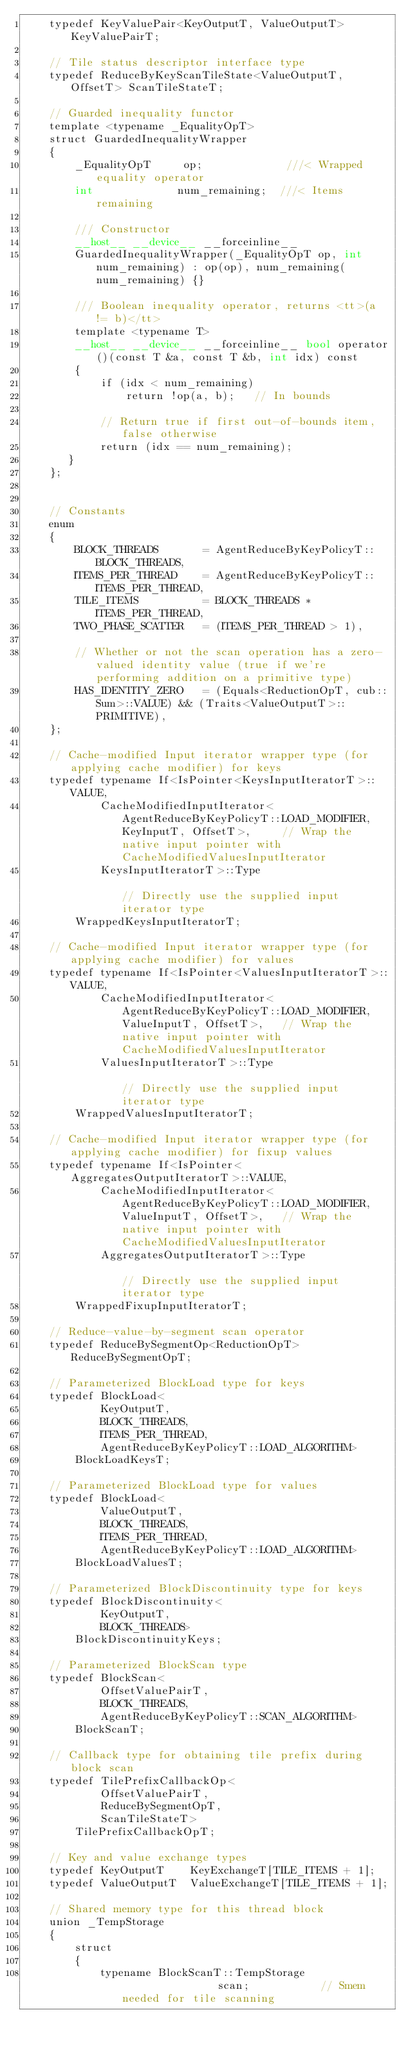<code> <loc_0><loc_0><loc_500><loc_500><_Cuda_>    typedef KeyValuePair<KeyOutputT, ValueOutputT> KeyValuePairT;

    // Tile status descriptor interface type
    typedef ReduceByKeyScanTileState<ValueOutputT, OffsetT> ScanTileStateT;

    // Guarded inequality functor
    template <typename _EqualityOpT>
    struct GuardedInequalityWrapper
    {
        _EqualityOpT     op;             ///< Wrapped equality operator
        int             num_remaining;  ///< Items remaining

        /// Constructor
        __host__ __device__ __forceinline__
        GuardedInequalityWrapper(_EqualityOpT op, int num_remaining) : op(op), num_remaining(num_remaining) {}

        /// Boolean inequality operator, returns <tt>(a != b)</tt>
        template <typename T>
        __host__ __device__ __forceinline__ bool operator()(const T &a, const T &b, int idx) const
        {
            if (idx < num_remaining)
                return !op(a, b);   // In bounds

            // Return true if first out-of-bounds item, false otherwise
            return (idx == num_remaining);
       }
    };


    // Constants
    enum
    {
        BLOCK_THREADS       = AgentReduceByKeyPolicyT::BLOCK_THREADS,
        ITEMS_PER_THREAD    = AgentReduceByKeyPolicyT::ITEMS_PER_THREAD,
        TILE_ITEMS          = BLOCK_THREADS * ITEMS_PER_THREAD,
        TWO_PHASE_SCATTER   = (ITEMS_PER_THREAD > 1),

        // Whether or not the scan operation has a zero-valued identity value (true if we're performing addition on a primitive type)
        HAS_IDENTITY_ZERO   = (Equals<ReductionOpT, cub::Sum>::VALUE) && (Traits<ValueOutputT>::PRIMITIVE),
    };

    // Cache-modified Input iterator wrapper type (for applying cache modifier) for keys
    typedef typename If<IsPointer<KeysInputIteratorT>::VALUE,
            CacheModifiedInputIterator<AgentReduceByKeyPolicyT::LOAD_MODIFIER, KeyInputT, OffsetT>,     // Wrap the native input pointer with CacheModifiedValuesInputIterator
            KeysInputIteratorT>::Type                                                                   // Directly use the supplied input iterator type
        WrappedKeysInputIteratorT;

    // Cache-modified Input iterator wrapper type (for applying cache modifier) for values
    typedef typename If<IsPointer<ValuesInputIteratorT>::VALUE,
            CacheModifiedInputIterator<AgentReduceByKeyPolicyT::LOAD_MODIFIER, ValueInputT, OffsetT>,   // Wrap the native input pointer with CacheModifiedValuesInputIterator
            ValuesInputIteratorT>::Type                                                                 // Directly use the supplied input iterator type
        WrappedValuesInputIteratorT;

    // Cache-modified Input iterator wrapper type (for applying cache modifier) for fixup values
    typedef typename If<IsPointer<AggregatesOutputIteratorT>::VALUE,
            CacheModifiedInputIterator<AgentReduceByKeyPolicyT::LOAD_MODIFIER, ValueInputT, OffsetT>,   // Wrap the native input pointer with CacheModifiedValuesInputIterator
            AggregatesOutputIteratorT>::Type                                                            // Directly use the supplied input iterator type
        WrappedFixupInputIteratorT;

    // Reduce-value-by-segment scan operator
    typedef ReduceBySegmentOp<ReductionOpT> ReduceBySegmentOpT;

    // Parameterized BlockLoad type for keys
    typedef BlockLoad<
            KeyOutputT,
            BLOCK_THREADS,
            ITEMS_PER_THREAD,
            AgentReduceByKeyPolicyT::LOAD_ALGORITHM>
        BlockLoadKeysT;

    // Parameterized BlockLoad type for values
    typedef BlockLoad<
            ValueOutputT,
            BLOCK_THREADS,
            ITEMS_PER_THREAD,
            AgentReduceByKeyPolicyT::LOAD_ALGORITHM>
        BlockLoadValuesT;

    // Parameterized BlockDiscontinuity type for keys
    typedef BlockDiscontinuity<
            KeyOutputT,
            BLOCK_THREADS>
        BlockDiscontinuityKeys;

    // Parameterized BlockScan type
    typedef BlockScan<
            OffsetValuePairT,
            BLOCK_THREADS,
            AgentReduceByKeyPolicyT::SCAN_ALGORITHM>
        BlockScanT;

    // Callback type for obtaining tile prefix during block scan
    typedef TilePrefixCallbackOp<
            OffsetValuePairT,
            ReduceBySegmentOpT,
            ScanTileStateT>
        TilePrefixCallbackOpT;

    // Key and value exchange types
    typedef KeyOutputT    KeyExchangeT[TILE_ITEMS + 1];
    typedef ValueOutputT  ValueExchangeT[TILE_ITEMS + 1];

    // Shared memory type for this thread block
    union _TempStorage
    {
        struct
        {
            typename BlockScanT::TempStorage                scan;           // Smem needed for tile scanning</code> 